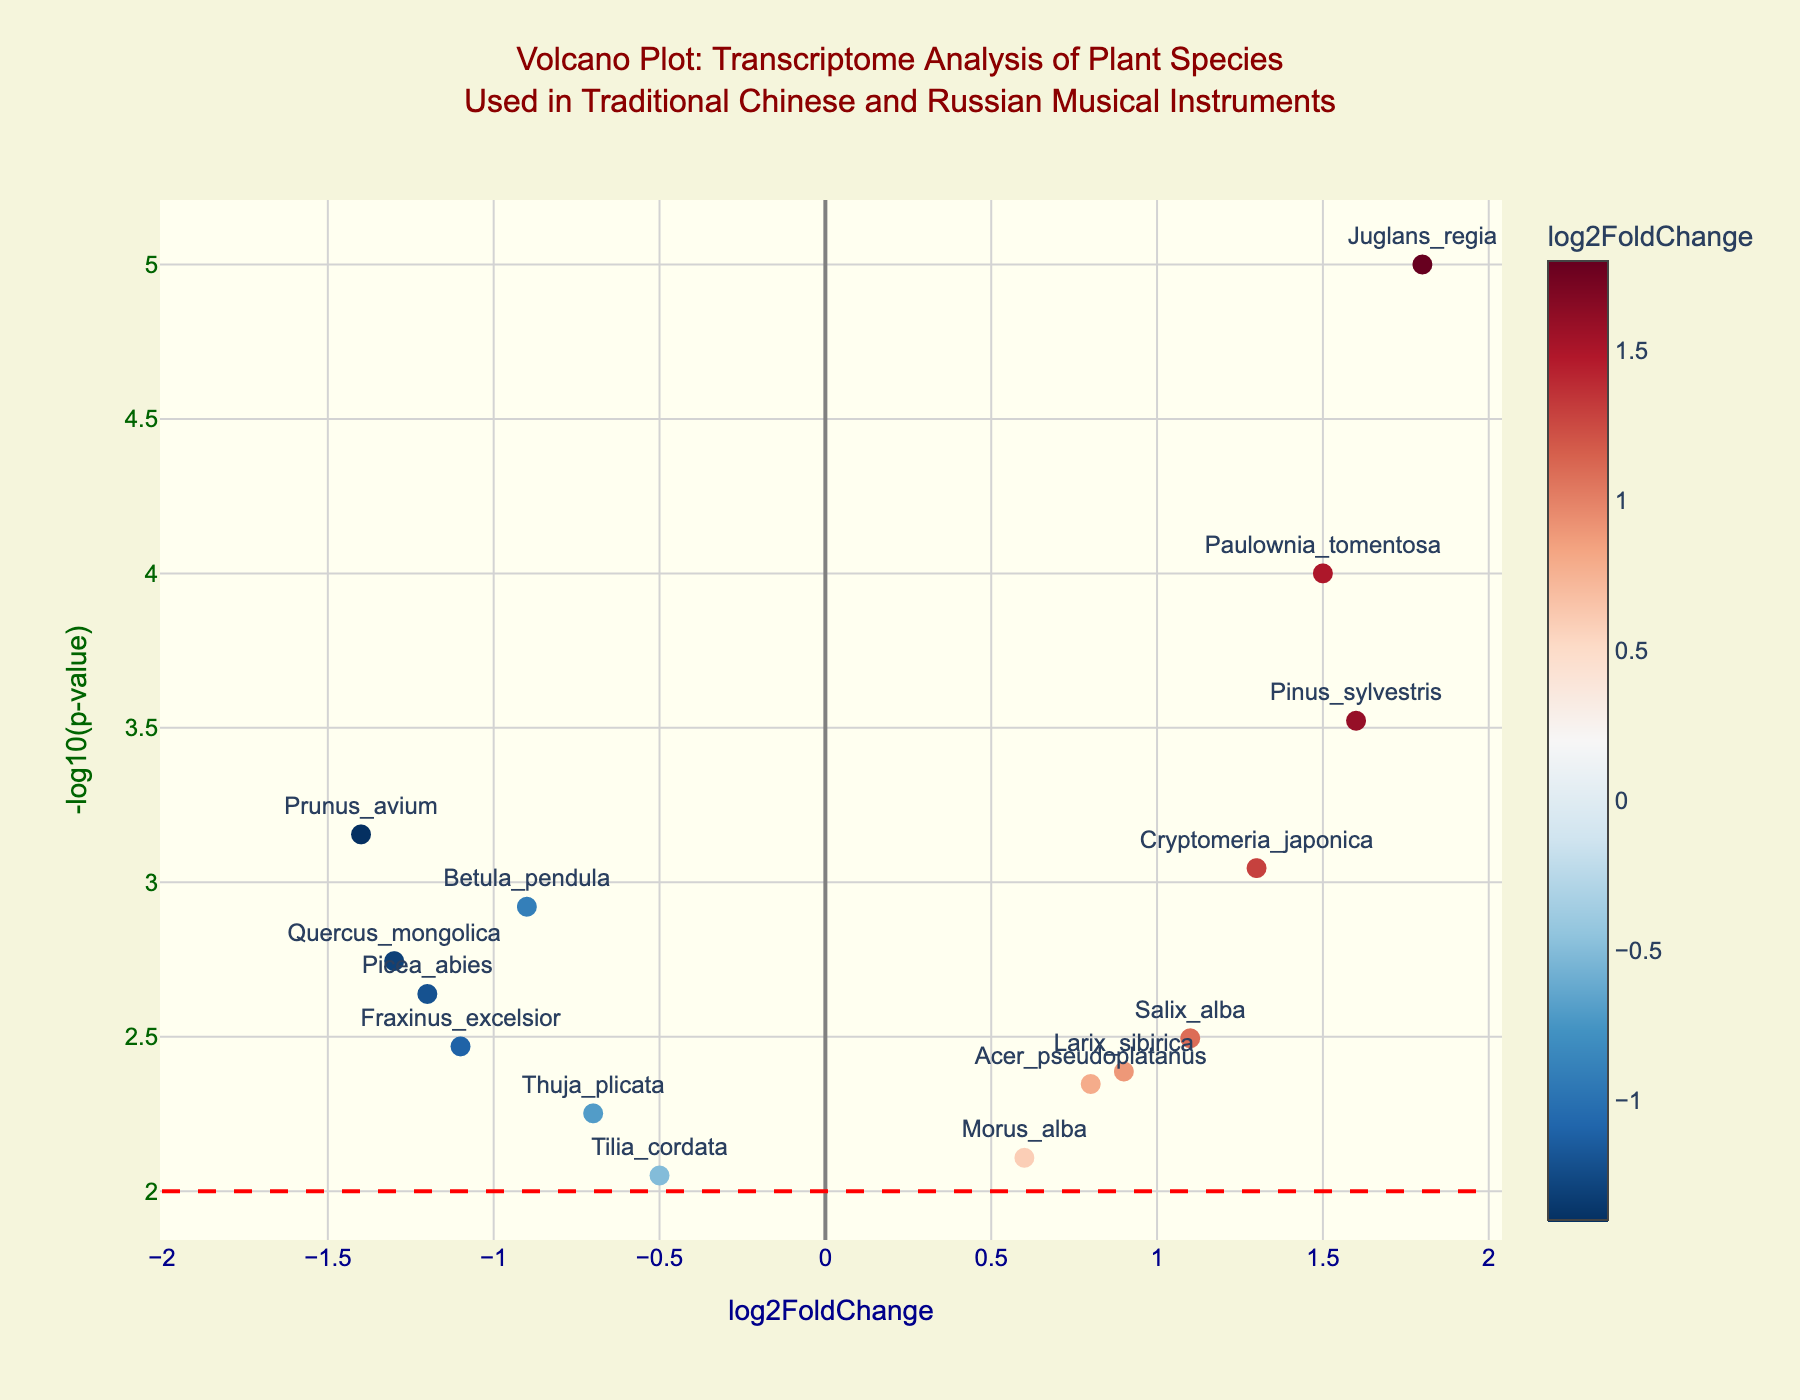What is the title of the Volcano Plot? The title is typically found at the top center of the plot. In this figure, the title is 'Volcano Plot: Transcriptome Analysis of Plant Species Used in Traditional Chinese and Russian Musical Instruments'.
Answer: Volcano Plot: Transcriptome Analysis of Plant Species Used in Traditional Chinese and Russian Musical Instruments What do the x and y axes represent in the Volcano Plot? By looking at the labels on the axes, the x-axis represents 'log2FoldChange', and the y-axis represents '-log10(p-value)'.
Answer: The x-axis represents 'log2FoldChange', and the y-axis represents '-log10(p-value)' Which gene has the highest log2FoldChange? To find the gene with the highest log2FoldChange, observe the gene farthest to the right on the x-axis. The gene 'Juglans_regia' has the highest log2FoldChange at 1.8.
Answer: Juglans_regia How many genes have a p-value less than 0.005? Identify the genes with -log10(p-value) values greater than the -log10(0.005) threshold. This calculation gives -log10(0.005) ≈ 2.3. The genes above this threshold are: Picea_abies, Acer_pseudoplatanus, Betula_pendula, Paulownia_tomentosa, Fraxinus_excelsior, Cryptomeria_japonica, Prunus_avium, Salix_alba, Pinus_sylvestris, and Quercus_mongolica (10 genes).
Answer: 10 genes Which gene has the smallest p-value, and what is it? The smallest p-value corresponds to the highest -log10(p-value) value. The gene 'Juglans_regia' has the highest -log10(p-value) value, which means it has the smallest p-value of 0.00001.
Answer: Juglans_regia, 0.00001 What is the range of log2FoldChange values in the plot? The range is determined by finding the maximum and minimum x-axis values. The maximum log2FoldChange is 1.8 (Juglans_regia), and the minimum is -1.4 (Prunus_avium), giving a range of -1.4 to 1.8.
Answer: -1.4 to 1.8 Of the genes with a log2FoldChange greater than 1, which one has the largest -log10(p-value)? For genes with log2FoldChange greater than 1, compare their -log10(p-value) values. The gene 'Juglans_regia' has the largest -log10(p-value) at approximately 5.
Answer: Juglans_regia How many genes are labeled on the plot? Count the number of text labels next to the data points. Each label is a gene name, and there are 15 labeled genes.
Answer: 15 genes 